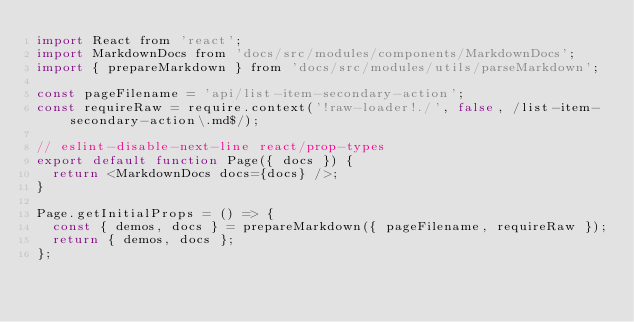Convert code to text. <code><loc_0><loc_0><loc_500><loc_500><_JavaScript_>import React from 'react';
import MarkdownDocs from 'docs/src/modules/components/MarkdownDocs';
import { prepareMarkdown } from 'docs/src/modules/utils/parseMarkdown';

const pageFilename = 'api/list-item-secondary-action';
const requireRaw = require.context('!raw-loader!./', false, /list-item-secondary-action\.md$/);

// eslint-disable-next-line react/prop-types
export default function Page({ docs }) {
  return <MarkdownDocs docs={docs} />;
}

Page.getInitialProps = () => {
  const { demos, docs } = prepareMarkdown({ pageFilename, requireRaw });
  return { demos, docs };
};
</code> 